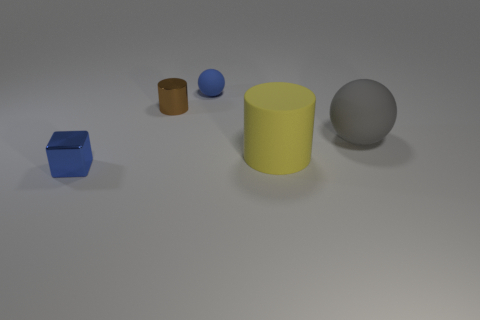Add 3 tiny rubber balls. How many objects exist? 8 Subtract all blocks. How many objects are left? 4 Add 2 small blue blocks. How many small blue blocks are left? 3 Add 3 tiny brown metallic cylinders. How many tiny brown metallic cylinders exist? 4 Subtract 0 cyan cubes. How many objects are left? 5 Subtract all green matte cylinders. Subtract all gray spheres. How many objects are left? 4 